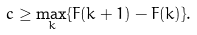<formula> <loc_0><loc_0><loc_500><loc_500>c \geq \max _ { k } \{ F ( k + 1 ) - F ( k ) \} .</formula> 